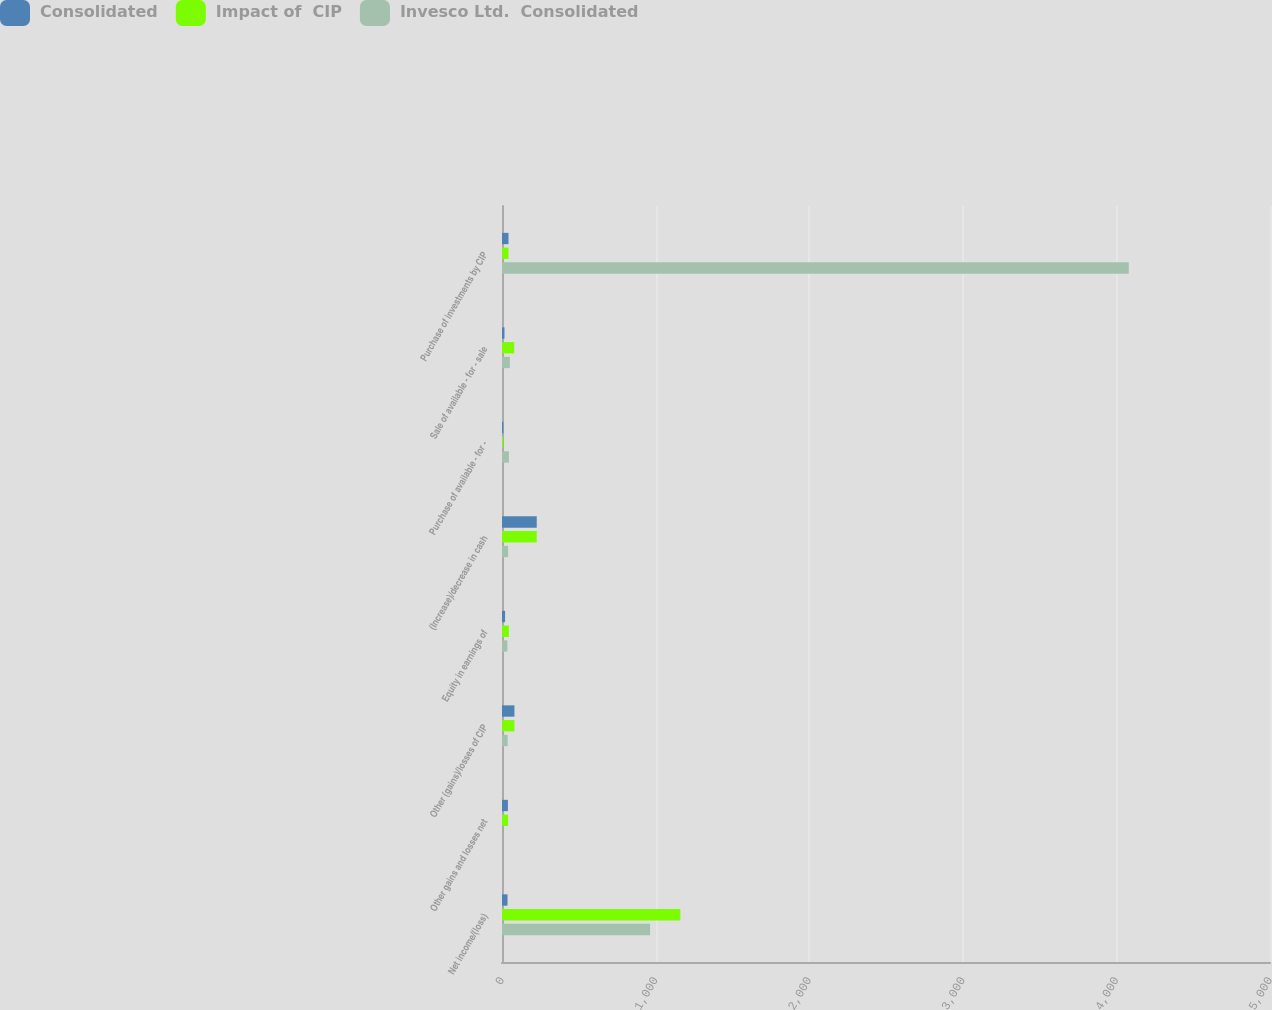Convert chart. <chart><loc_0><loc_0><loc_500><loc_500><stacked_bar_chart><ecel><fcel>Net income/(loss)<fcel>Other gains and losses net<fcel>Other (gains)/losses of CIP<fcel>Equity in earnings of<fcel>(Increase)/decrease in cash<fcel>Purchase of available - for -<fcel>Sale of available - for - sale<fcel>Purchase of investments by CIP<nl><fcel>Consolidated<fcel>36<fcel>38.4<fcel>81<fcel>20<fcel>226.2<fcel>8.7<fcel>16.2<fcel>42.3<nl><fcel>Impact of  CIP<fcel>1161<fcel>39.4<fcel>81<fcel>44.7<fcel>226.2<fcel>7.9<fcel>79.5<fcel>42.3<nl><fcel>Invesco Ltd.  Consolidated<fcel>964.1<fcel>1.5<fcel>37<fcel>35.1<fcel>39.9<fcel>44.9<fcel>51.1<fcel>4080.7<nl></chart> 